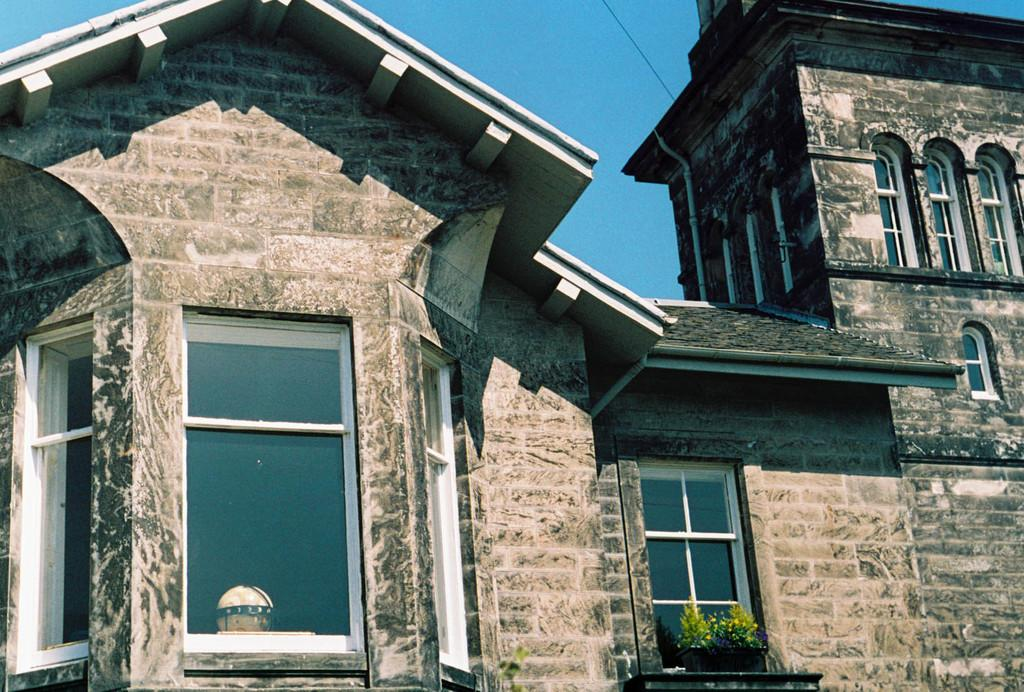What type of structure is present in the image? There is a building in the image. What feature can be seen on the building? The building has windows. Are there any plants visible in the image? Yes, there are two plants in the image. What is the top part of the building called? The building has a roof. What can be seen in the background of the image? The sky is visible in the background of the image. What type of wood is used to construct the prison in the image? There is no prison present in the image, and therefore no wood used for construction can be determined. 